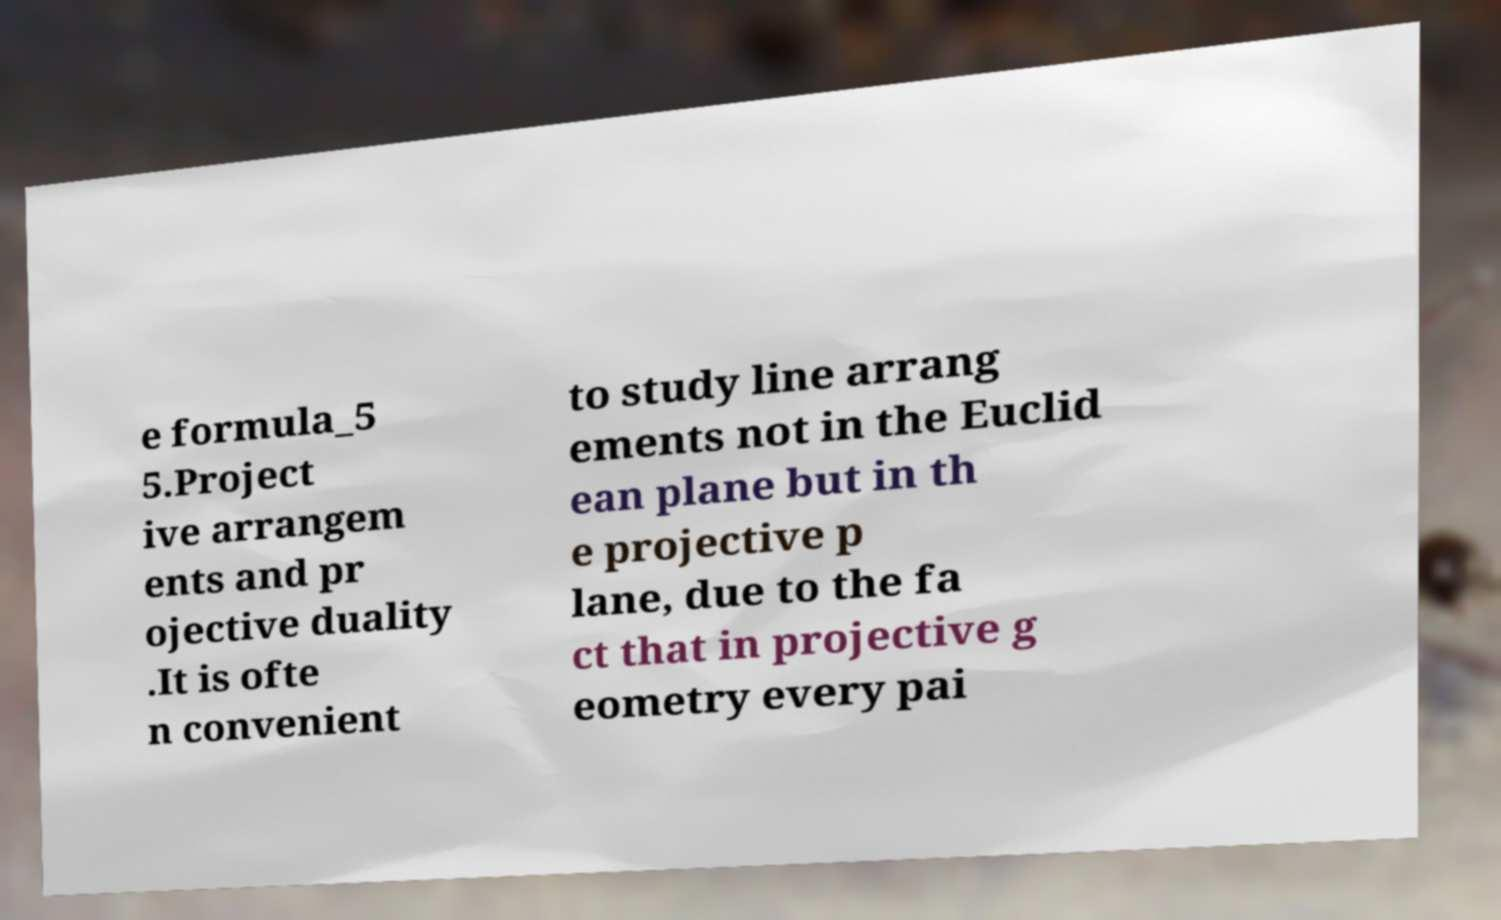There's text embedded in this image that I need extracted. Can you transcribe it verbatim? e formula_5 5.Project ive arrangem ents and pr ojective duality .It is ofte n convenient to study line arrang ements not in the Euclid ean plane but in th e projective p lane, due to the fa ct that in projective g eometry every pai 